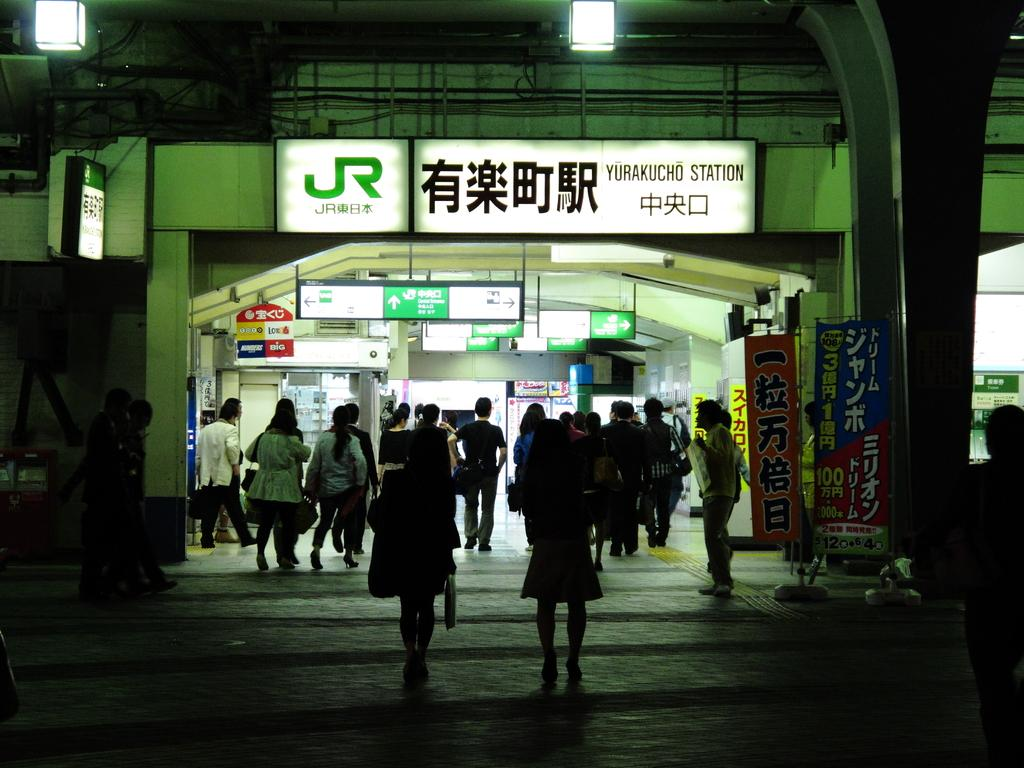<image>
Render a clear and concise summary of the photo. People entering and leaving Yurakucho station with a sign that says JR. 